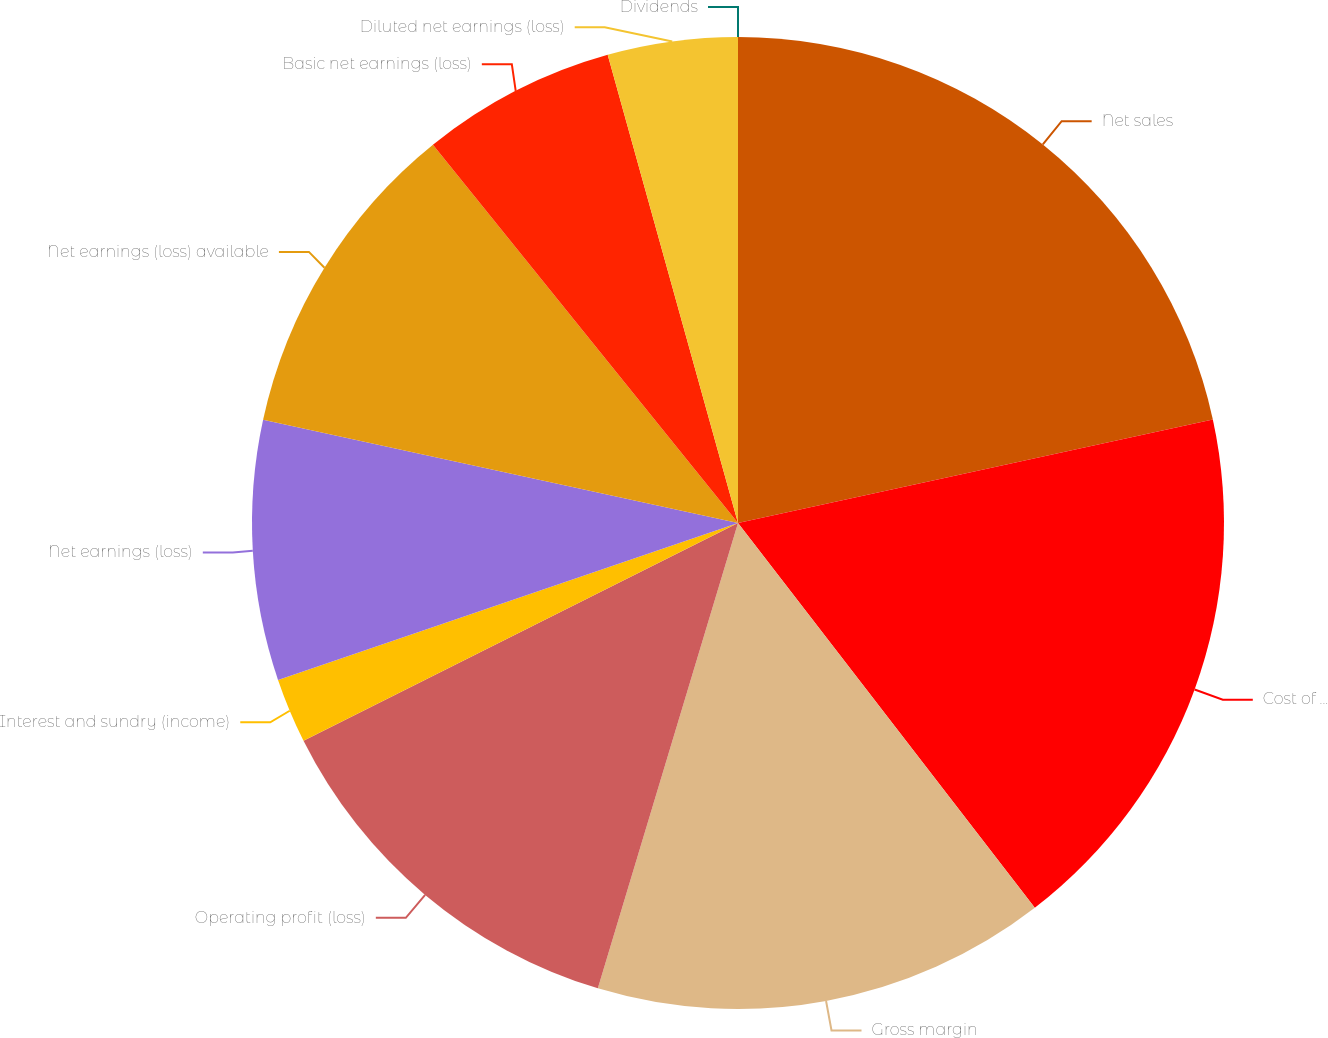Convert chart. <chart><loc_0><loc_0><loc_500><loc_500><pie_chart><fcel>Net sales<fcel>Cost of products sold<fcel>Gross margin<fcel>Operating profit (loss)<fcel>Interest and sundry (income)<fcel>Net earnings (loss)<fcel>Net earnings (loss) available<fcel>Basic net earnings (loss)<fcel>Diluted net earnings (loss)<fcel>Dividends<nl><fcel>21.58%<fcel>17.96%<fcel>15.11%<fcel>12.95%<fcel>2.16%<fcel>8.64%<fcel>10.79%<fcel>6.48%<fcel>4.32%<fcel>0.0%<nl></chart> 